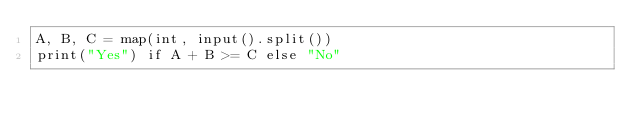<code> <loc_0><loc_0><loc_500><loc_500><_Python_>A, B, C = map(int, input().split())
print("Yes") if A + B >= C else "No"
  </code> 